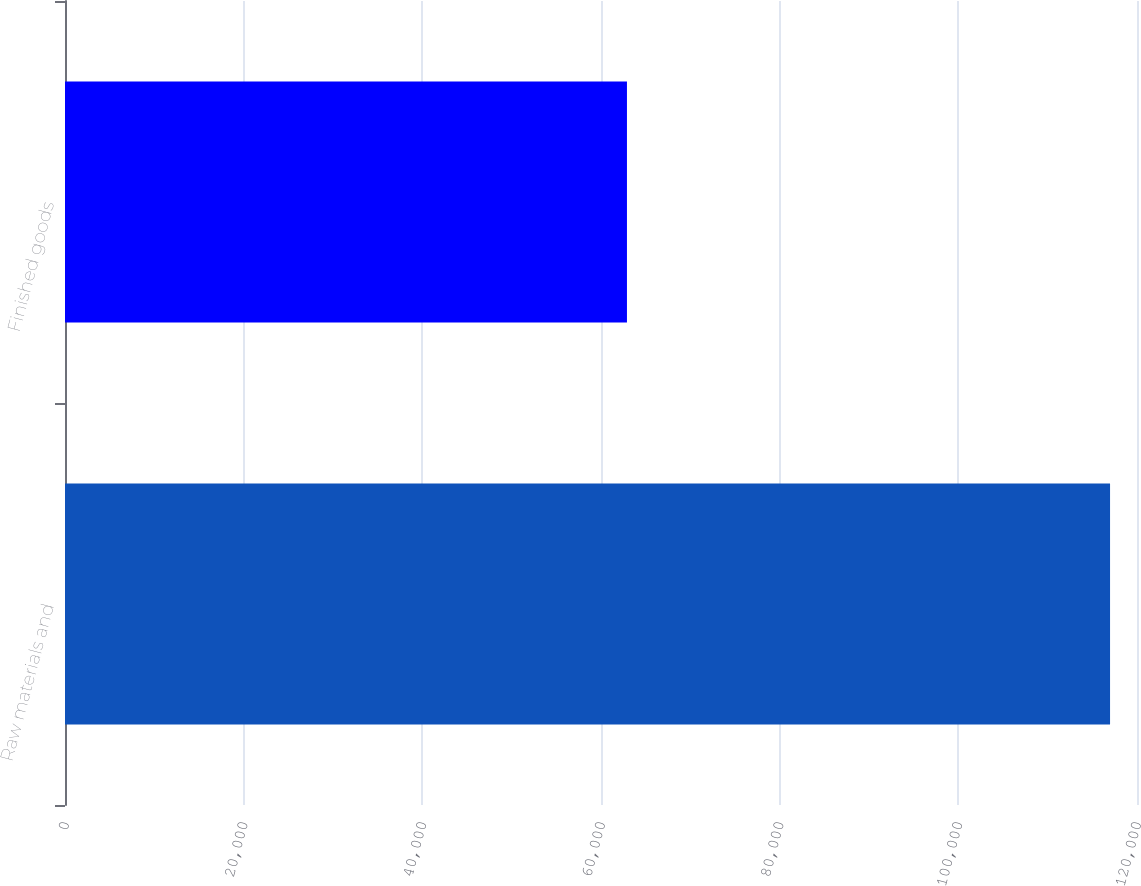Convert chart to OTSL. <chart><loc_0><loc_0><loc_500><loc_500><bar_chart><fcel>Raw materials and<fcel>Finished goods<nl><fcel>116983<fcel>62906<nl></chart> 